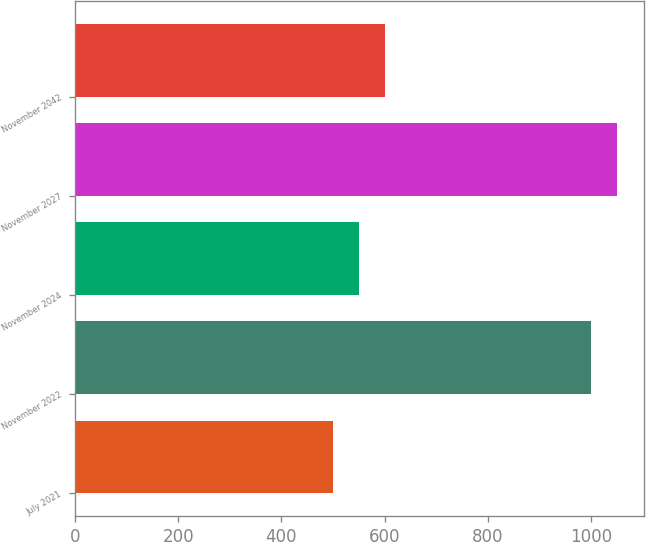Convert chart to OTSL. <chart><loc_0><loc_0><loc_500><loc_500><bar_chart><fcel>July 2021<fcel>November 2022<fcel>November 2024<fcel>November 2027<fcel>November 2042<nl><fcel>500<fcel>1000<fcel>550<fcel>1050<fcel>600<nl></chart> 